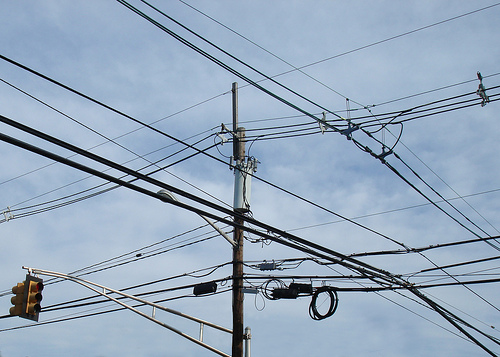<image>
Is there a traffic light in front of the telephone pole? No. The traffic light is not in front of the telephone pole. The spatial positioning shows a different relationship between these objects. 